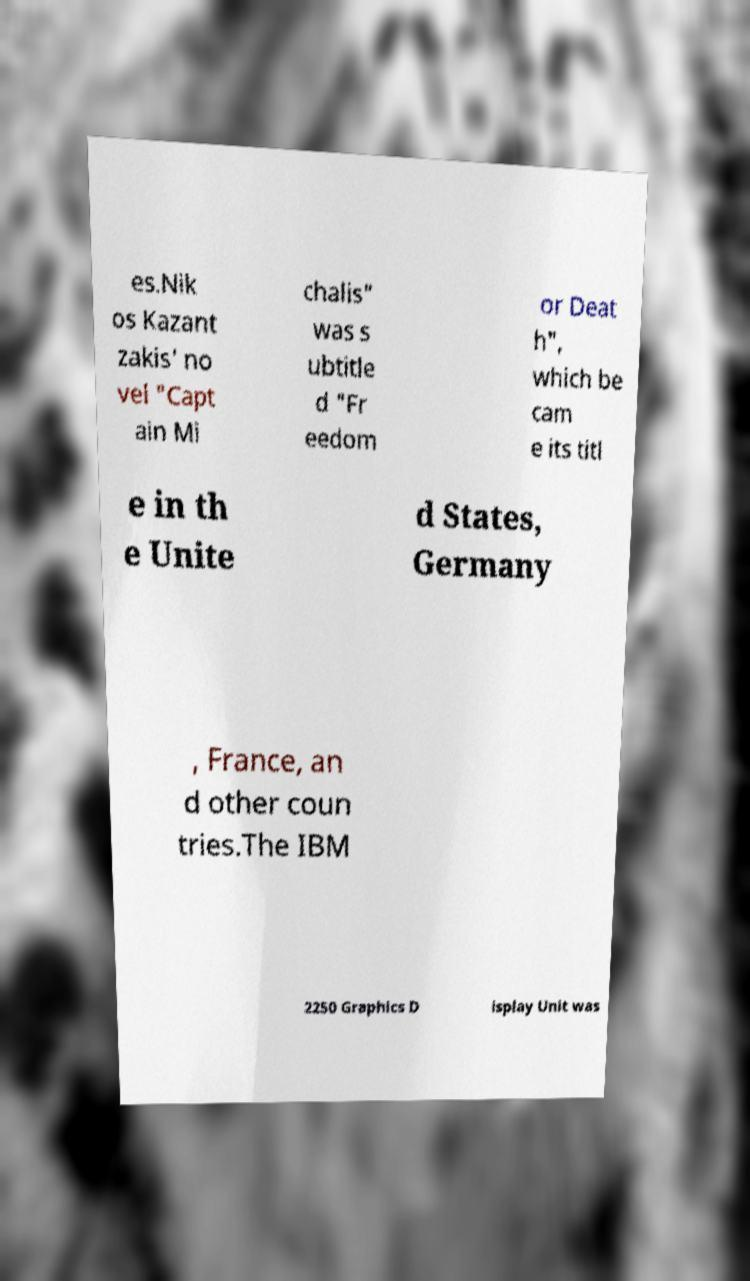For documentation purposes, I need the text within this image transcribed. Could you provide that? es.Nik os Kazant zakis' no vel "Capt ain Mi chalis" was s ubtitle d "Fr eedom or Deat h", which be cam e its titl e in th e Unite d States, Germany , France, an d other coun tries.The IBM 2250 Graphics D isplay Unit was 